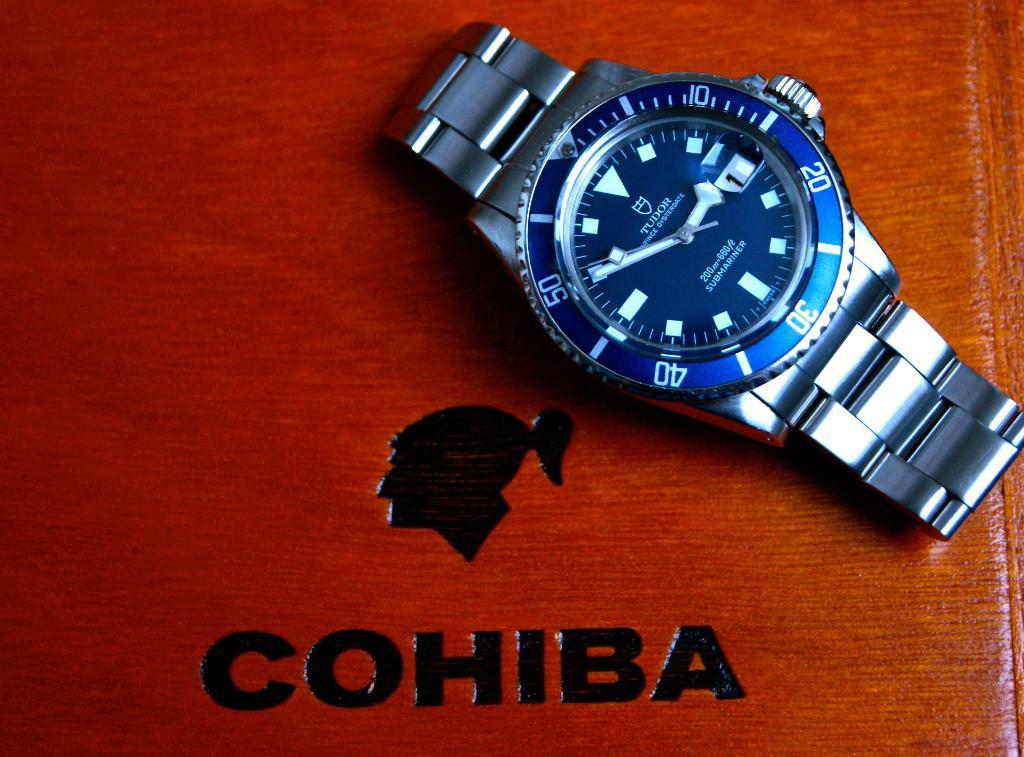<image>
Relay a brief, clear account of the picture shown. A watch is on display on top of a wooden box that reads "Cohiba." 